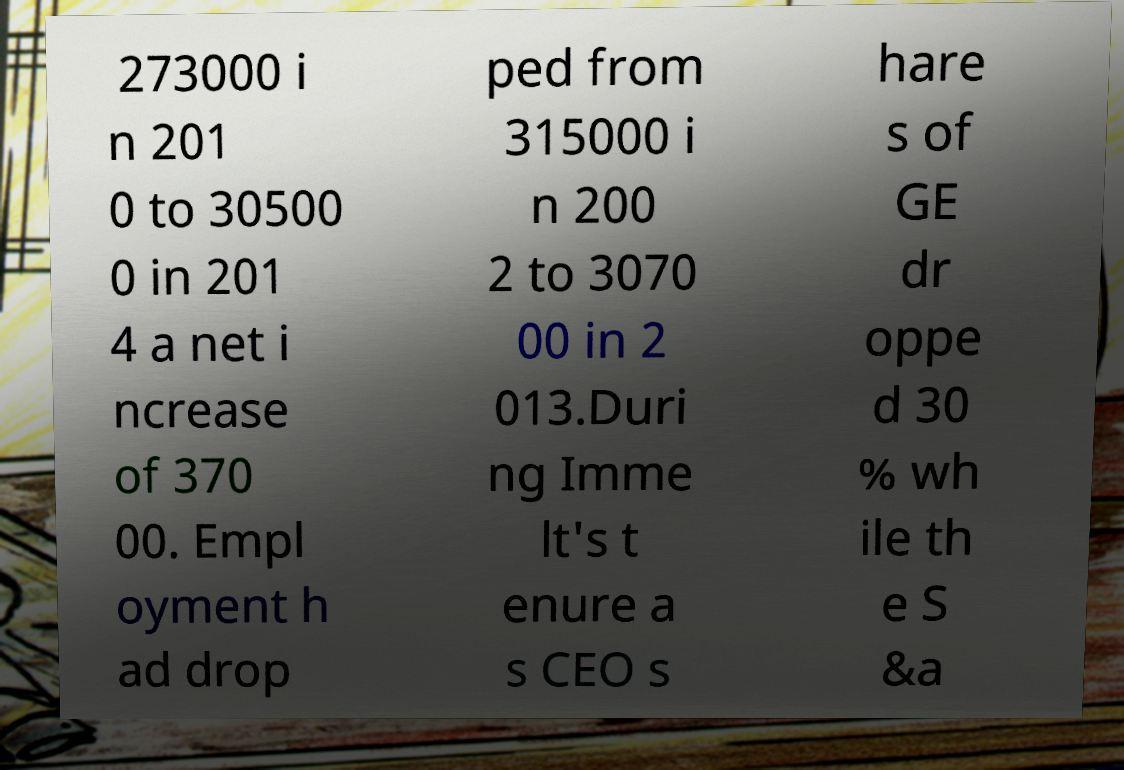Could you extract and type out the text from this image? 273000 i n 201 0 to 30500 0 in 201 4 a net i ncrease of 370 00. Empl oyment h ad drop ped from 315000 i n 200 2 to 3070 00 in 2 013.Duri ng Imme lt's t enure a s CEO s hare s of GE dr oppe d 30 % wh ile th e S &a 